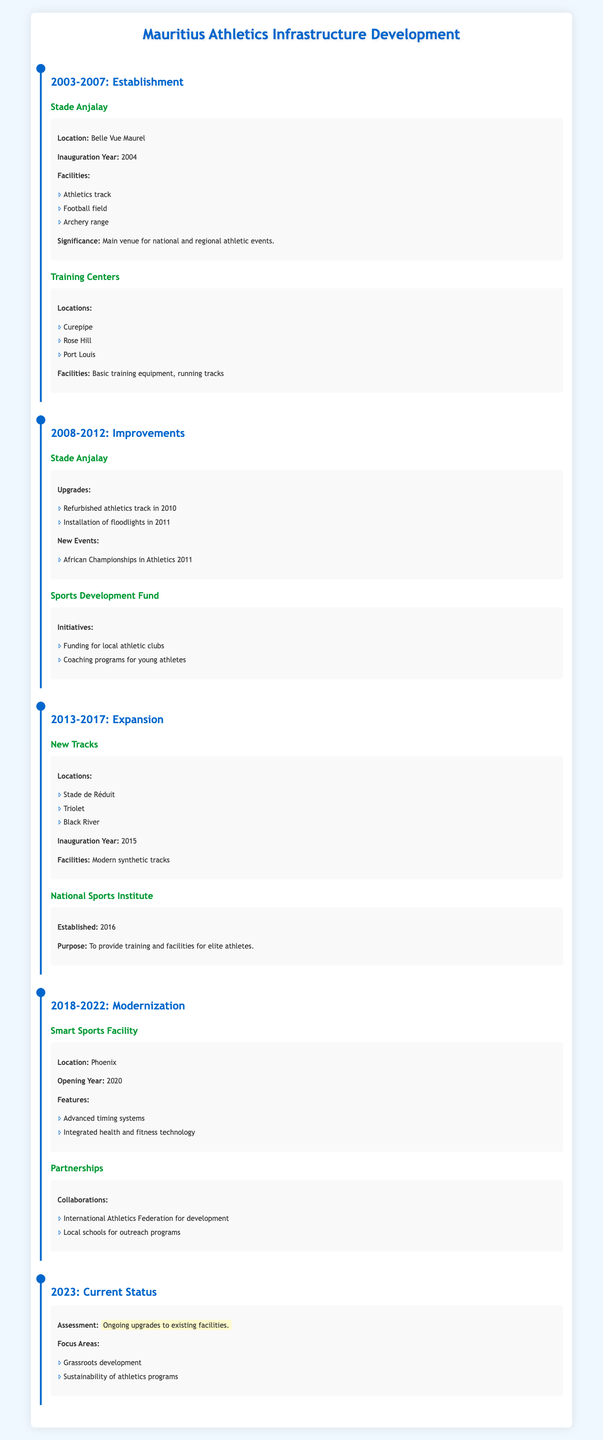What year was Stade Anjalay inaugurated? The table under the 2003-2007 section states that Stade Anjalay was inaugurated in 2004.
Answer: 2004 What facilities are available at Stade Anjalay? The section detailing Stade Anjalay in the 2003-2007 period lists three facilities: an athletics track, a football field, and an archery range.
Answer: Athletics track, football field, archery range Did the Infrastructure Development include the establishment of a National Sports Institute? Yes, the table mentions under the 2013-2017 section that the National Sports Institute was established in 2016.
Answer: Yes How many new tracks were inaugurated in 2015, and where are they located? The 2013-2017 section lists three new tracks inaugurated in 2015, located at Stade de Réduit, Triolet, and Black River.
Answer: 3, Stade de Réduit, Triolet, Black River What improvements were made to Stade Anjalay between 2008 and 2012? The improvements section mentions two specific upgrades: the athletics track was refurbished in 2010, and floodlights were installed in 2011.
Answer: Refurbished athletics track in 2010, installation of floodlights in 2011 What is the purpose of the National Sports Institute established in 2016? The purpose is stated in the 2013-2017 section as providing training and facilities for elite athletes.
Answer: To provide training and facilities for elite athletes Are the recent infrastructure developments focusing on grassroots development? Yes, the current status section mentions that one of the focus areas is grassroots development.
Answer: Yes What features were included in the Smart Sports Facility opened in 2020? The table lists two features under the Smart Sports Facility: advanced timing systems and integrated health and fitness technology.
Answer: Advanced timing systems, integrated health and fitness technology What was the primary focus of the Sports Development Fund during the 2008-2012 period? The table indicates that the Sports Development Fund focused on funding local athletic clubs and establishing coaching programs for young athletes during that period.
Answer: Funding local athletic clubs, coaching programs for young athletes How does the assessment of infrastructure development in 2023 reflect ongoing changes? The current status section states that there are ongoing upgrades to existing facilities, focusing on sustainability of athletics programs and grassroots development, indicating continuous improvement.
Answer: Ongoing upgrades to existing facilities, focus on sustainability and grassroots development 